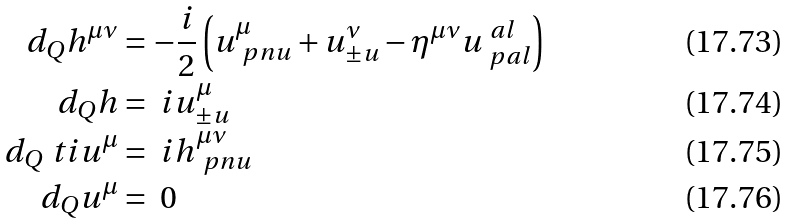<formula> <loc_0><loc_0><loc_500><loc_500>d _ { Q } h ^ { \mu \nu } & = - \frac { i } { 2 } \left ( u ^ { \mu } _ { \ p n u } + u ^ { \nu } _ { \pm u } - \eta ^ { \mu \nu } u ^ { \ a l } _ { \ p a l } \right ) \\ d _ { Q } h & = \ i u ^ { \mu } _ { \pm u } \\ d _ { Q } \ t i { u } ^ { \mu } & = \ i h ^ { \mu \nu } _ { \ p n u } \\ d _ { Q } u ^ { \mu } & = \ 0</formula> 